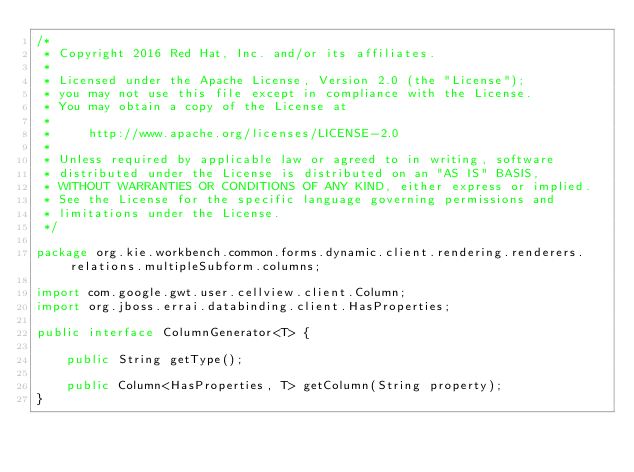<code> <loc_0><loc_0><loc_500><loc_500><_Java_>/*
 * Copyright 2016 Red Hat, Inc. and/or its affiliates.
 *
 * Licensed under the Apache License, Version 2.0 (the "License");
 * you may not use this file except in compliance with the License.
 * You may obtain a copy of the License at
 *
 *     http://www.apache.org/licenses/LICENSE-2.0
 *
 * Unless required by applicable law or agreed to in writing, software
 * distributed under the License is distributed on an "AS IS" BASIS,
 * WITHOUT WARRANTIES OR CONDITIONS OF ANY KIND, either express or implied.
 * See the License for the specific language governing permissions and
 * limitations under the License.
 */

package org.kie.workbench.common.forms.dynamic.client.rendering.renderers.relations.multipleSubform.columns;

import com.google.gwt.user.cellview.client.Column;
import org.jboss.errai.databinding.client.HasProperties;

public interface ColumnGenerator<T> {

    public String getType();

    public Column<HasProperties, T> getColumn(String property);
}
</code> 